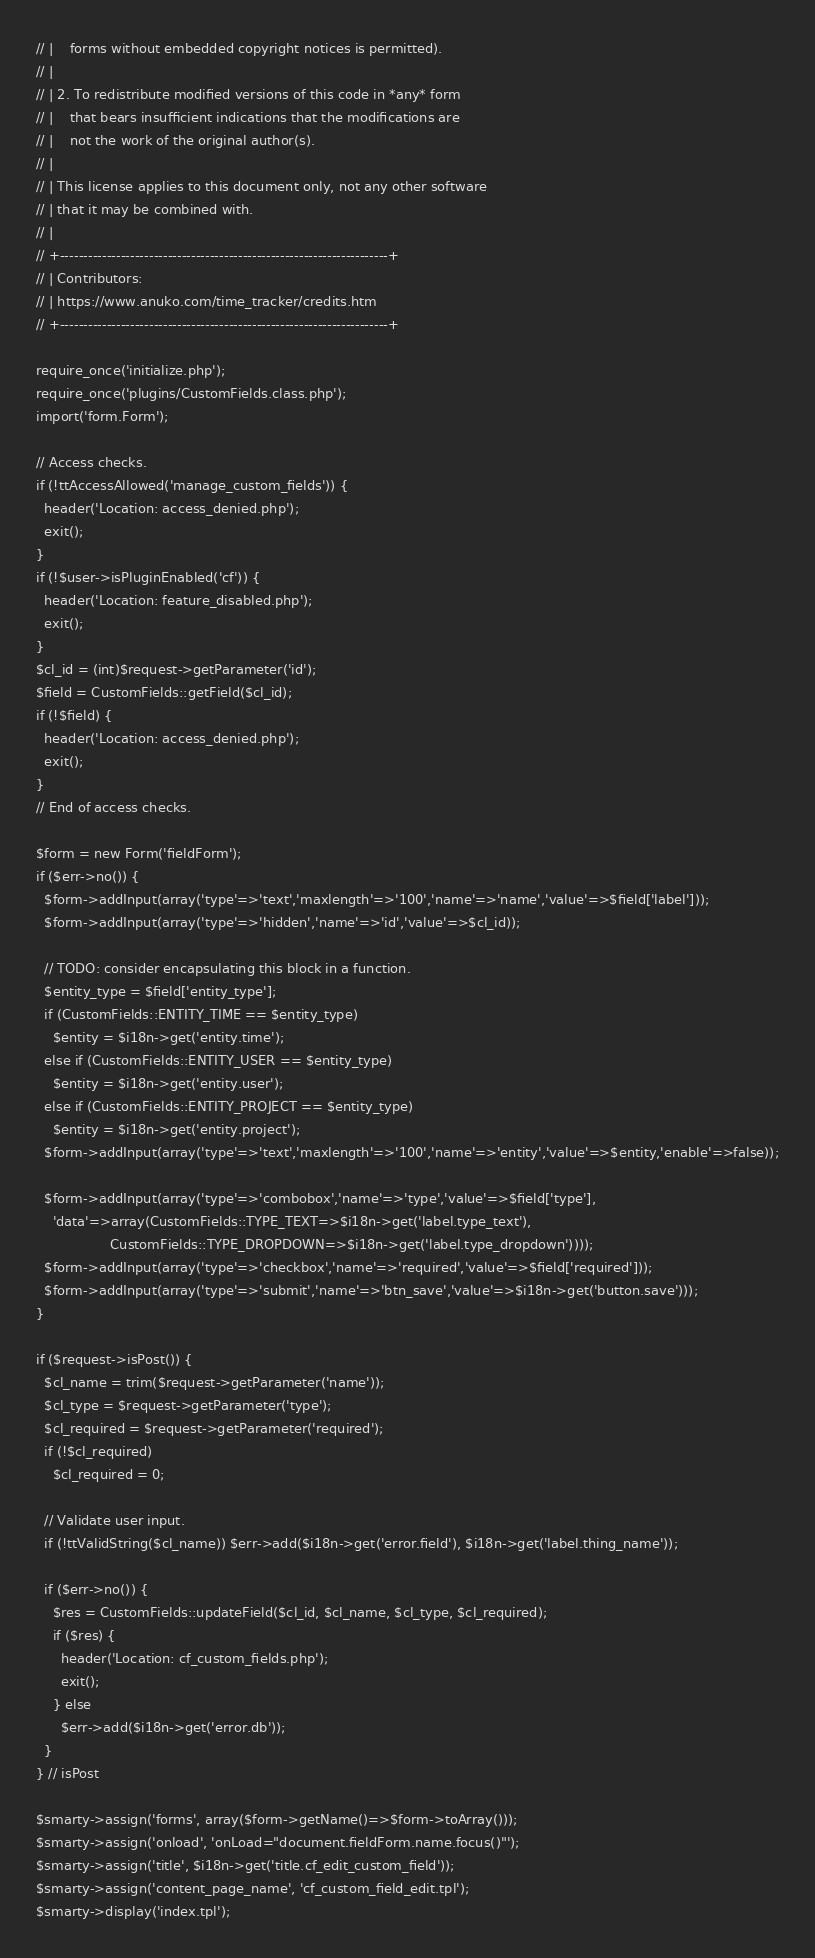Convert code to text. <code><loc_0><loc_0><loc_500><loc_500><_PHP_>// |    forms without embedded copyright notices is permitted).
// |
// | 2. To redistribute modified versions of this code in *any* form
// |    that bears insufficient indications that the modifications are
// |    not the work of the original author(s).
// |
// | This license applies to this document only, not any other software
// | that it may be combined with.
// |
// +----------------------------------------------------------------------+
// | Contributors:
// | https://www.anuko.com/time_tracker/credits.htm
// +----------------------------------------------------------------------+

require_once('initialize.php');
require_once('plugins/CustomFields.class.php');
import('form.Form');

// Access checks.
if (!ttAccessAllowed('manage_custom_fields')) {
  header('Location: access_denied.php');
  exit();
}
if (!$user->isPluginEnabled('cf')) {
  header('Location: feature_disabled.php');
  exit();
}
$cl_id = (int)$request->getParameter('id');
$field = CustomFields::getField($cl_id);
if (!$field) {
  header('Location: access_denied.php');
  exit();
}
// End of access checks.

$form = new Form('fieldForm');
if ($err->no()) {
  $form->addInput(array('type'=>'text','maxlength'=>'100','name'=>'name','value'=>$field['label']));
  $form->addInput(array('type'=>'hidden','name'=>'id','value'=>$cl_id));

  // TODO: consider encapsulating this block in a function.
  $entity_type = $field['entity_type'];
  if (CustomFields::ENTITY_TIME == $entity_type)
    $entity = $i18n->get('entity.time');
  else if (CustomFields::ENTITY_USER == $entity_type)
    $entity = $i18n->get('entity.user');
  else if (CustomFields::ENTITY_PROJECT == $entity_type)
    $entity = $i18n->get('entity.project');
  $form->addInput(array('type'=>'text','maxlength'=>'100','name'=>'entity','value'=>$entity,'enable'=>false));

  $form->addInput(array('type'=>'combobox','name'=>'type','value'=>$field['type'],
    'data'=>array(CustomFields::TYPE_TEXT=>$i18n->get('label.type_text'),
                  CustomFields::TYPE_DROPDOWN=>$i18n->get('label.type_dropdown'))));
  $form->addInput(array('type'=>'checkbox','name'=>'required','value'=>$field['required']));
  $form->addInput(array('type'=>'submit','name'=>'btn_save','value'=>$i18n->get('button.save')));
}

if ($request->isPost()) {
  $cl_name = trim($request->getParameter('name'));
  $cl_type = $request->getParameter('type');
  $cl_required = $request->getParameter('required');
  if (!$cl_required)
    $cl_required = 0;

  // Validate user input.
  if (!ttValidString($cl_name)) $err->add($i18n->get('error.field'), $i18n->get('label.thing_name'));

  if ($err->no()) {
    $res = CustomFields::updateField($cl_id, $cl_name, $cl_type, $cl_required);
    if ($res) {
      header('Location: cf_custom_fields.php');
      exit();
    } else
      $err->add($i18n->get('error.db'));
  }
} // isPost

$smarty->assign('forms', array($form->getName()=>$form->toArray()));
$smarty->assign('onload', 'onLoad="document.fieldForm.name.focus()"');
$smarty->assign('title', $i18n->get('title.cf_edit_custom_field'));
$smarty->assign('content_page_name', 'cf_custom_field_edit.tpl');
$smarty->display('index.tpl');
</code> 